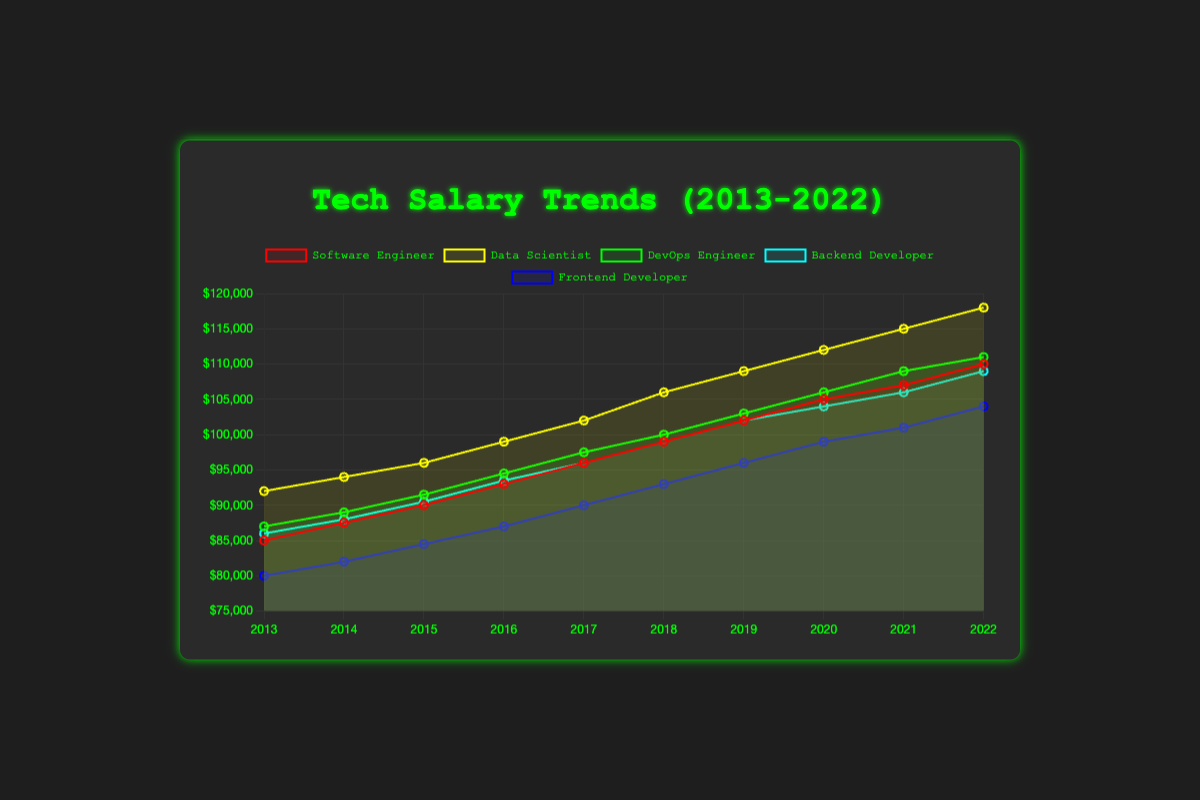Which role has the highest salary in 2022? The highest salary in 2022 can be seen by comparing the end points of each line. The Data Scientist role's line ends at the highest point on the y-axis, indicating the highest salary at $118,000.
Answer: Data Scientist What is the average salary of a DevOps Engineer from 2013 to 2022? Sum the salaries for DevOps Engineer across all years and then divide by 10. The total is ($87,000 + $89,000 + $91,500 + $94,500 + $97,500 + $100,000 + $103,000 + $106,000 + $109,000 + $111,000) = $978,500, so the average is $978,500 / 10 = $97,850.
Answer: $97,850 Which role had the steepest increase in salary between 2016 and 2017? By examining the slopes of the lines between 2016 and 2017, we see that the Data Scientist role has the steepest increase from $99,000 to $102,000, an increase of $3,000.
Answer: Data Scientist What was the difference in salary between a Backend Developer and a Frontend Developer in 2018? Look at the y-values of the Backend Developer and Frontend Developer lines at 2018. Backend Developer salary is $99,000 and Frontend Developer salary is $93,000. The difference is $99,000 - $93,000 = $6,000.
Answer: $6,000 Which year saw the highest salary increase for Software Engineers? Review the year-to-year increments of the Software Engineer line. The largest increase occurs between 2016 and 2017, where the salary increased from $93,000 to $96,000, an increase of $3,000.
Answer: 2017 By how much did the average salary of all roles increase from 2013 to 2022? Calculate the initial average salary in 2013 and the final average salary in 2022: 2013 average = ($85,000 + $92,000 + $87,000 + $86,000 + $80,000) / 5 = $86,000; 2022 average = ($110,000 + $118,000 + $111,000 + $109,000 + $104,000) / 5 = $110,400. The increase is $110,400 - $86,000 = $24,400.
Answer: $24,400 Which role consistently had the lowest salary across the decade? Trace each line over the decade and identify which one tends to stay at the bottom. The Frontend Developer role consistently has the lowest salary compared to the other roles.
Answer: Frontend Developer In which year were the salaries of Software Engineers and DevOps Engineers equal? Look at the points of intersection between the lines of Software Engineers and DevOps Engineers. At 2013, both roles had the same salary of $87,000.
Answer: None 